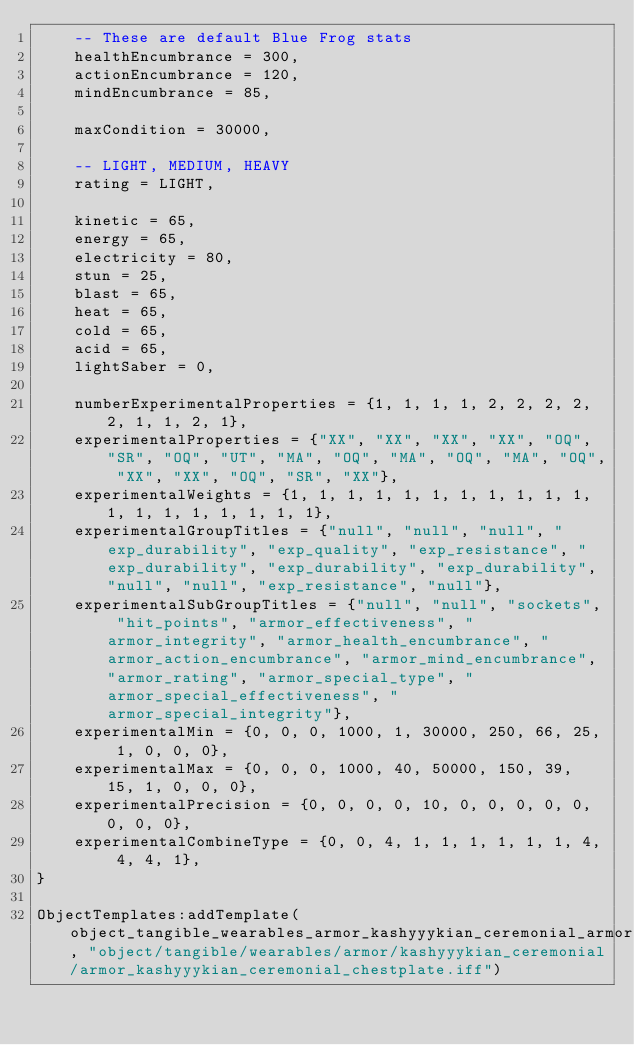<code> <loc_0><loc_0><loc_500><loc_500><_Lua_>	-- These are default Blue Frog stats
	healthEncumbrance = 300,
	actionEncumbrance = 120,
	mindEncumbrance = 85,

	maxCondition = 30000,

	-- LIGHT, MEDIUM, HEAVY
	rating = LIGHT,

	kinetic = 65,
	energy = 65,
	electricity = 80,
	stun = 25,
	blast = 65,
	heat = 65,
	cold = 65,
	acid = 65,
	lightSaber = 0,

	numberExperimentalProperties = {1, 1, 1, 1, 2, 2, 2, 2, 2, 1, 1, 2, 1},
	experimentalProperties = {"XX", "XX", "XX", "XX", "OQ", "SR", "OQ", "UT", "MA", "OQ", "MA", "OQ", "MA", "OQ", "XX", "XX", "OQ", "SR", "XX"},
	experimentalWeights = {1, 1, 1, 1, 1, 1, 1, 1, 1, 1, 1, 1, 1, 1, 1, 1, 1, 1, 1},
	experimentalGroupTitles = {"null", "null", "null", "exp_durability", "exp_quality", "exp_resistance", "exp_durability", "exp_durability", "exp_durability", "null", "null", "exp_resistance", "null"},
	experimentalSubGroupTitles = {"null", "null", "sockets", "hit_points", "armor_effectiveness", "armor_integrity", "armor_health_encumbrance", "armor_action_encumbrance", "armor_mind_encumbrance", "armor_rating", "armor_special_type", "armor_special_effectiveness", "armor_special_integrity"},
	experimentalMin = {0, 0, 0, 1000, 1, 30000, 250, 66, 25, 1, 0, 0, 0},
	experimentalMax = {0, 0, 0, 1000, 40, 50000, 150, 39, 15, 1, 0, 0, 0},
	experimentalPrecision = {0, 0, 0, 0, 10, 0, 0, 0, 0, 0, 0, 0, 0},
	experimentalCombineType = {0, 0, 4, 1, 1, 1, 1, 1, 1, 4, 4, 4, 1},
}

ObjectTemplates:addTemplate(object_tangible_wearables_armor_kashyyykian_ceremonial_armor_kashyyykian_ceremonial_chestplate, "object/tangible/wearables/armor/kashyyykian_ceremonial/armor_kashyyykian_ceremonial_chestplate.iff")
</code> 